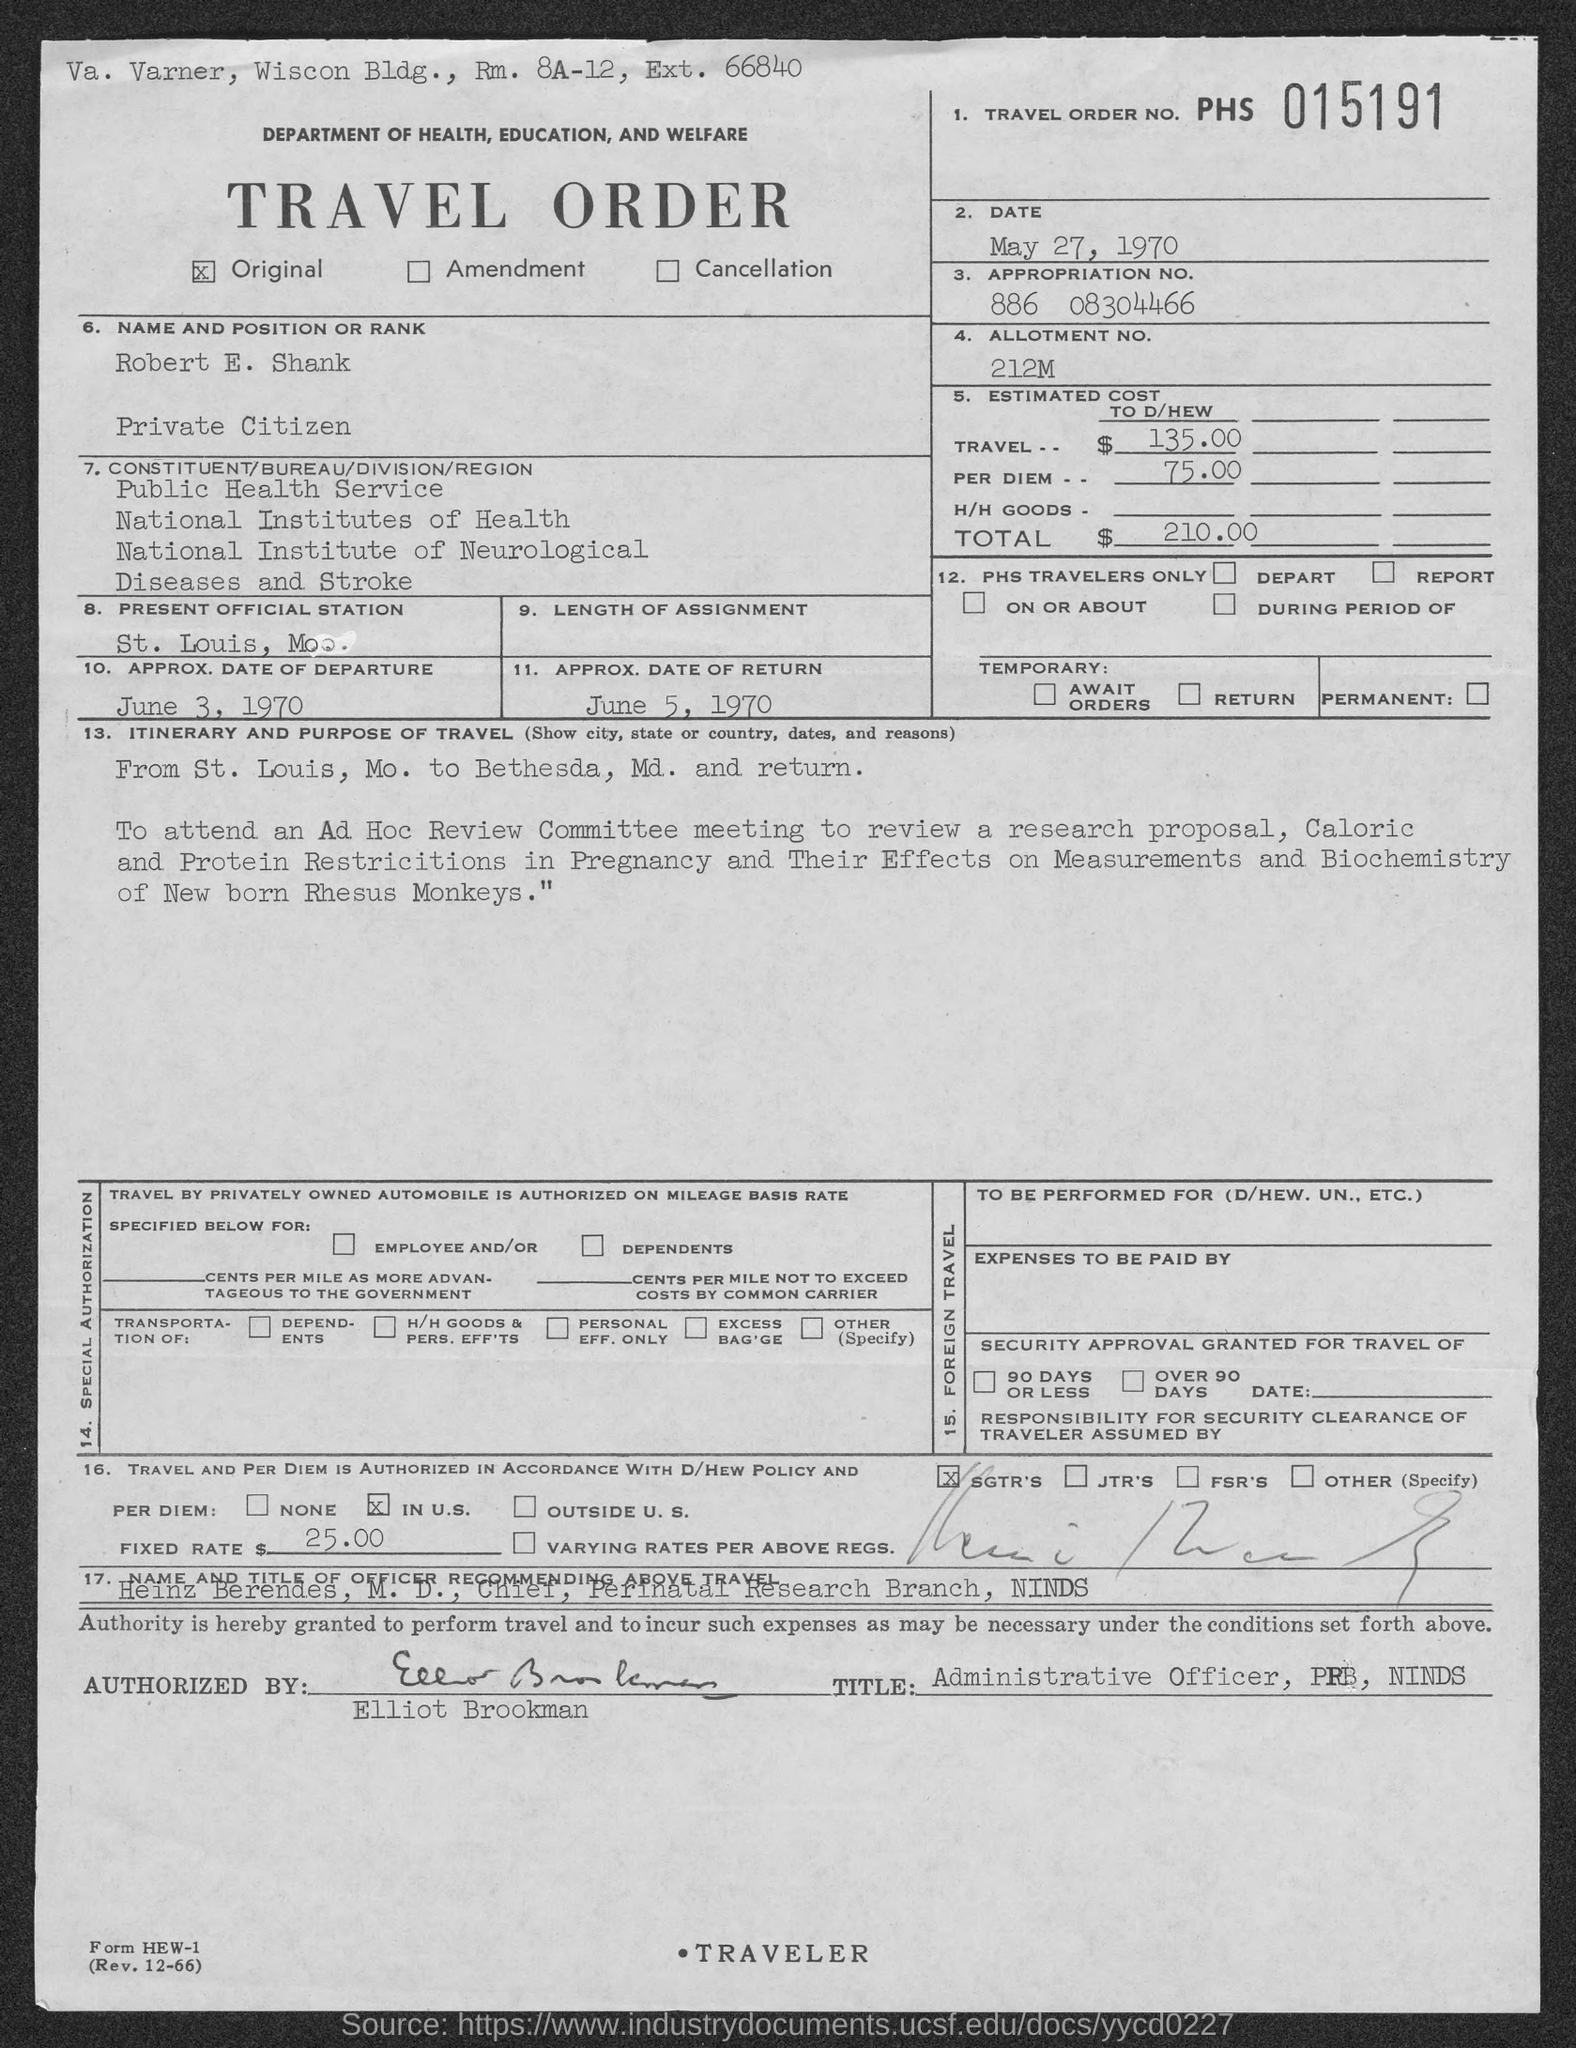What is the travel order no. ?
Your response must be concise. 015191. Is the travel order original?
Offer a terse response. Yes. What is the date in travel order ?
Make the answer very short. May 27, 1970. What is allotment no.?
Your answer should be compact. 212M. What is the approx. date of departure ?
Offer a very short reply. June 3, 1970. What is the approx. date of return ?
Your response must be concise. June 5, 1970. What is the total estimated costs ?
Provide a succinct answer. $210.00. 